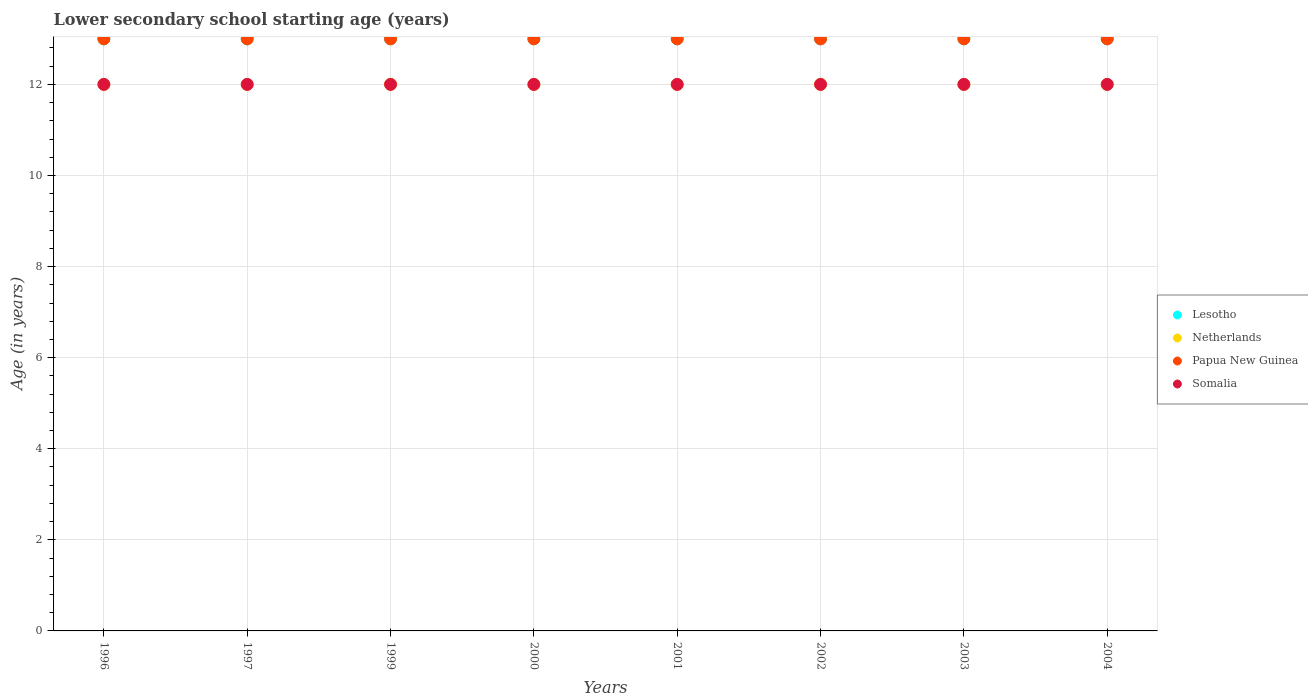Is the number of dotlines equal to the number of legend labels?
Your response must be concise. Yes. What is the lower secondary school starting age of children in Papua New Guinea in 2003?
Offer a terse response. 13. Across all years, what is the maximum lower secondary school starting age of children in Papua New Guinea?
Your answer should be compact. 13. Across all years, what is the minimum lower secondary school starting age of children in Netherlands?
Your response must be concise. 12. In which year was the lower secondary school starting age of children in Netherlands minimum?
Make the answer very short. 1996. What is the total lower secondary school starting age of children in Netherlands in the graph?
Your answer should be compact. 96. What is the difference between the lower secondary school starting age of children in Somalia in 1996 and that in 1999?
Your answer should be compact. 0. In the year 2000, what is the difference between the lower secondary school starting age of children in Somalia and lower secondary school starting age of children in Netherlands?
Make the answer very short. 0. In how many years, is the lower secondary school starting age of children in Netherlands greater than 1.2000000000000002 years?
Provide a succinct answer. 8. Is the difference between the lower secondary school starting age of children in Somalia in 2001 and 2003 greater than the difference between the lower secondary school starting age of children in Netherlands in 2001 and 2003?
Offer a terse response. No. What is the difference between the highest and the second highest lower secondary school starting age of children in Lesotho?
Offer a terse response. 0. Is the sum of the lower secondary school starting age of children in Lesotho in 1999 and 2002 greater than the maximum lower secondary school starting age of children in Papua New Guinea across all years?
Offer a very short reply. Yes. Is it the case that in every year, the sum of the lower secondary school starting age of children in Somalia and lower secondary school starting age of children in Netherlands  is greater than the lower secondary school starting age of children in Papua New Guinea?
Give a very brief answer. Yes. How many dotlines are there?
Offer a very short reply. 4. What is the difference between two consecutive major ticks on the Y-axis?
Make the answer very short. 2. Does the graph contain any zero values?
Provide a succinct answer. No. How are the legend labels stacked?
Provide a succinct answer. Vertical. What is the title of the graph?
Make the answer very short. Lower secondary school starting age (years). What is the label or title of the Y-axis?
Give a very brief answer. Age (in years). What is the Age (in years) of Netherlands in 1996?
Your response must be concise. 12. What is the Age (in years) in Papua New Guinea in 1997?
Provide a short and direct response. 13. What is the Age (in years) of Papua New Guinea in 1999?
Give a very brief answer. 13. What is the Age (in years) in Lesotho in 2001?
Provide a succinct answer. 13. What is the Age (in years) of Papua New Guinea in 2001?
Make the answer very short. 13. What is the Age (in years) in Somalia in 2001?
Give a very brief answer. 12. What is the Age (in years) of Lesotho in 2002?
Your response must be concise. 13. What is the Age (in years) of Papua New Guinea in 2002?
Your answer should be very brief. 13. What is the Age (in years) in Somalia in 2002?
Your answer should be very brief. 12. What is the Age (in years) of Lesotho in 2003?
Your answer should be very brief. 13. What is the Age (in years) in Netherlands in 2003?
Provide a succinct answer. 12. What is the Age (in years) of Papua New Guinea in 2003?
Make the answer very short. 13. What is the Age (in years) of Somalia in 2003?
Offer a terse response. 12. What is the Age (in years) of Lesotho in 2004?
Provide a short and direct response. 13. What is the Age (in years) in Netherlands in 2004?
Ensure brevity in your answer.  12. What is the Age (in years) in Somalia in 2004?
Provide a short and direct response. 12. Across all years, what is the minimum Age (in years) of Lesotho?
Provide a succinct answer. 13. Across all years, what is the minimum Age (in years) in Somalia?
Keep it short and to the point. 12. What is the total Age (in years) of Lesotho in the graph?
Give a very brief answer. 104. What is the total Age (in years) in Netherlands in the graph?
Ensure brevity in your answer.  96. What is the total Age (in years) of Papua New Guinea in the graph?
Keep it short and to the point. 104. What is the total Age (in years) of Somalia in the graph?
Provide a succinct answer. 96. What is the difference between the Age (in years) of Netherlands in 1996 and that in 1997?
Make the answer very short. 0. What is the difference between the Age (in years) in Lesotho in 1996 and that in 1999?
Your answer should be compact. 0. What is the difference between the Age (in years) of Lesotho in 1996 and that in 2000?
Ensure brevity in your answer.  0. What is the difference between the Age (in years) in Somalia in 1996 and that in 2000?
Your answer should be very brief. 0. What is the difference between the Age (in years) of Netherlands in 1996 and that in 2001?
Your answer should be very brief. 0. What is the difference between the Age (in years) in Papua New Guinea in 1996 and that in 2001?
Ensure brevity in your answer.  0. What is the difference between the Age (in years) of Lesotho in 1996 and that in 2002?
Your answer should be compact. 0. What is the difference between the Age (in years) in Netherlands in 1996 and that in 2002?
Your response must be concise. 0. What is the difference between the Age (in years) of Somalia in 1996 and that in 2002?
Offer a terse response. 0. What is the difference between the Age (in years) in Netherlands in 1996 and that in 2003?
Provide a short and direct response. 0. What is the difference between the Age (in years) of Papua New Guinea in 1996 and that in 2003?
Your answer should be compact. 0. What is the difference between the Age (in years) of Netherlands in 1996 and that in 2004?
Your answer should be compact. 0. What is the difference between the Age (in years) of Papua New Guinea in 1996 and that in 2004?
Provide a succinct answer. 0. What is the difference between the Age (in years) of Lesotho in 1997 and that in 1999?
Provide a succinct answer. 0. What is the difference between the Age (in years) in Papua New Guinea in 1997 and that in 1999?
Ensure brevity in your answer.  0. What is the difference between the Age (in years) of Somalia in 1997 and that in 1999?
Your answer should be very brief. 0. What is the difference between the Age (in years) in Papua New Guinea in 1997 and that in 2000?
Offer a very short reply. 0. What is the difference between the Age (in years) in Somalia in 1997 and that in 2000?
Your response must be concise. 0. What is the difference between the Age (in years) of Netherlands in 1997 and that in 2001?
Keep it short and to the point. 0. What is the difference between the Age (in years) of Papua New Guinea in 1997 and that in 2001?
Give a very brief answer. 0. What is the difference between the Age (in years) in Somalia in 1997 and that in 2002?
Your answer should be compact. 0. What is the difference between the Age (in years) in Netherlands in 1997 and that in 2003?
Give a very brief answer. 0. What is the difference between the Age (in years) in Somalia in 1997 and that in 2003?
Your answer should be very brief. 0. What is the difference between the Age (in years) in Netherlands in 1997 and that in 2004?
Your answer should be very brief. 0. What is the difference between the Age (in years) in Papua New Guinea in 1997 and that in 2004?
Your answer should be compact. 0. What is the difference between the Age (in years) of Lesotho in 1999 and that in 2000?
Provide a short and direct response. 0. What is the difference between the Age (in years) in Lesotho in 1999 and that in 2001?
Keep it short and to the point. 0. What is the difference between the Age (in years) in Netherlands in 1999 and that in 2001?
Keep it short and to the point. 0. What is the difference between the Age (in years) in Papua New Guinea in 1999 and that in 2001?
Provide a succinct answer. 0. What is the difference between the Age (in years) of Papua New Guinea in 1999 and that in 2002?
Make the answer very short. 0. What is the difference between the Age (in years) in Somalia in 1999 and that in 2002?
Your answer should be very brief. 0. What is the difference between the Age (in years) of Netherlands in 1999 and that in 2003?
Your answer should be compact. 0. What is the difference between the Age (in years) in Netherlands in 1999 and that in 2004?
Offer a very short reply. 0. What is the difference between the Age (in years) of Papua New Guinea in 2000 and that in 2001?
Keep it short and to the point. 0. What is the difference between the Age (in years) in Lesotho in 2000 and that in 2002?
Offer a very short reply. 0. What is the difference between the Age (in years) of Netherlands in 2000 and that in 2002?
Your answer should be very brief. 0. What is the difference between the Age (in years) of Somalia in 2000 and that in 2003?
Your response must be concise. 0. What is the difference between the Age (in years) in Papua New Guinea in 2000 and that in 2004?
Offer a terse response. 0. What is the difference between the Age (in years) in Somalia in 2000 and that in 2004?
Offer a terse response. 0. What is the difference between the Age (in years) of Lesotho in 2001 and that in 2002?
Keep it short and to the point. 0. What is the difference between the Age (in years) of Somalia in 2001 and that in 2002?
Offer a terse response. 0. What is the difference between the Age (in years) in Papua New Guinea in 2001 and that in 2003?
Make the answer very short. 0. What is the difference between the Age (in years) of Somalia in 2001 and that in 2003?
Offer a terse response. 0. What is the difference between the Age (in years) in Netherlands in 2001 and that in 2004?
Provide a short and direct response. 0. What is the difference between the Age (in years) of Papua New Guinea in 2001 and that in 2004?
Ensure brevity in your answer.  0. What is the difference between the Age (in years) of Somalia in 2001 and that in 2004?
Your answer should be very brief. 0. What is the difference between the Age (in years) of Netherlands in 2002 and that in 2004?
Make the answer very short. 0. What is the difference between the Age (in years) in Papua New Guinea in 2002 and that in 2004?
Offer a terse response. 0. What is the difference between the Age (in years) of Somalia in 2002 and that in 2004?
Give a very brief answer. 0. What is the difference between the Age (in years) of Lesotho in 2003 and that in 2004?
Give a very brief answer. 0. What is the difference between the Age (in years) in Somalia in 2003 and that in 2004?
Ensure brevity in your answer.  0. What is the difference between the Age (in years) in Lesotho in 1996 and the Age (in years) in Papua New Guinea in 1997?
Your answer should be very brief. 0. What is the difference between the Age (in years) of Lesotho in 1996 and the Age (in years) of Somalia in 1997?
Make the answer very short. 1. What is the difference between the Age (in years) in Netherlands in 1996 and the Age (in years) in Somalia in 1997?
Provide a succinct answer. 0. What is the difference between the Age (in years) of Lesotho in 1996 and the Age (in years) of Netherlands in 1999?
Your answer should be compact. 1. What is the difference between the Age (in years) of Lesotho in 1996 and the Age (in years) of Somalia in 1999?
Keep it short and to the point. 1. What is the difference between the Age (in years) in Netherlands in 1996 and the Age (in years) in Papua New Guinea in 1999?
Your answer should be very brief. -1. What is the difference between the Age (in years) of Netherlands in 1996 and the Age (in years) of Somalia in 1999?
Your response must be concise. 0. What is the difference between the Age (in years) in Lesotho in 1996 and the Age (in years) in Netherlands in 2000?
Ensure brevity in your answer.  1. What is the difference between the Age (in years) of Lesotho in 1996 and the Age (in years) of Somalia in 2000?
Keep it short and to the point. 1. What is the difference between the Age (in years) of Papua New Guinea in 1996 and the Age (in years) of Somalia in 2000?
Provide a succinct answer. 1. What is the difference between the Age (in years) in Lesotho in 1996 and the Age (in years) in Netherlands in 2001?
Offer a very short reply. 1. What is the difference between the Age (in years) of Lesotho in 1996 and the Age (in years) of Papua New Guinea in 2001?
Your answer should be very brief. 0. What is the difference between the Age (in years) in Netherlands in 1996 and the Age (in years) in Papua New Guinea in 2001?
Your response must be concise. -1. What is the difference between the Age (in years) of Netherlands in 1996 and the Age (in years) of Somalia in 2001?
Make the answer very short. 0. What is the difference between the Age (in years) in Lesotho in 1996 and the Age (in years) in Netherlands in 2002?
Keep it short and to the point. 1. What is the difference between the Age (in years) in Lesotho in 1996 and the Age (in years) in Papua New Guinea in 2002?
Ensure brevity in your answer.  0. What is the difference between the Age (in years) in Netherlands in 1996 and the Age (in years) in Papua New Guinea in 2002?
Give a very brief answer. -1. What is the difference between the Age (in years) of Papua New Guinea in 1996 and the Age (in years) of Somalia in 2002?
Your answer should be compact. 1. What is the difference between the Age (in years) of Lesotho in 1996 and the Age (in years) of Netherlands in 2003?
Your response must be concise. 1. What is the difference between the Age (in years) of Netherlands in 1996 and the Age (in years) of Somalia in 2003?
Provide a succinct answer. 0. What is the difference between the Age (in years) of Lesotho in 1996 and the Age (in years) of Somalia in 2004?
Your answer should be compact. 1. What is the difference between the Age (in years) of Netherlands in 1996 and the Age (in years) of Somalia in 2004?
Provide a succinct answer. 0. What is the difference between the Age (in years) of Papua New Guinea in 1996 and the Age (in years) of Somalia in 2004?
Your response must be concise. 1. What is the difference between the Age (in years) of Papua New Guinea in 1997 and the Age (in years) of Somalia in 1999?
Make the answer very short. 1. What is the difference between the Age (in years) in Lesotho in 1997 and the Age (in years) in Netherlands in 2000?
Offer a terse response. 1. What is the difference between the Age (in years) of Netherlands in 1997 and the Age (in years) of Papua New Guinea in 2000?
Provide a succinct answer. -1. What is the difference between the Age (in years) of Papua New Guinea in 1997 and the Age (in years) of Somalia in 2000?
Offer a terse response. 1. What is the difference between the Age (in years) of Lesotho in 1997 and the Age (in years) of Netherlands in 2001?
Your answer should be compact. 1. What is the difference between the Age (in years) of Lesotho in 1997 and the Age (in years) of Papua New Guinea in 2001?
Provide a succinct answer. 0. What is the difference between the Age (in years) in Netherlands in 1997 and the Age (in years) in Papua New Guinea in 2001?
Offer a very short reply. -1. What is the difference between the Age (in years) in Papua New Guinea in 1997 and the Age (in years) in Somalia in 2001?
Provide a short and direct response. 1. What is the difference between the Age (in years) in Lesotho in 1997 and the Age (in years) in Papua New Guinea in 2002?
Keep it short and to the point. 0. What is the difference between the Age (in years) in Lesotho in 1997 and the Age (in years) in Somalia in 2002?
Your answer should be compact. 1. What is the difference between the Age (in years) in Netherlands in 1997 and the Age (in years) in Papua New Guinea in 2002?
Offer a terse response. -1. What is the difference between the Age (in years) in Netherlands in 1997 and the Age (in years) in Somalia in 2002?
Make the answer very short. 0. What is the difference between the Age (in years) in Lesotho in 1997 and the Age (in years) in Netherlands in 2003?
Give a very brief answer. 1. What is the difference between the Age (in years) in Lesotho in 1997 and the Age (in years) in Somalia in 2003?
Offer a very short reply. 1. What is the difference between the Age (in years) of Netherlands in 1997 and the Age (in years) of Somalia in 2003?
Your answer should be compact. 0. What is the difference between the Age (in years) of Lesotho in 1997 and the Age (in years) of Netherlands in 2004?
Your answer should be very brief. 1. What is the difference between the Age (in years) of Lesotho in 1999 and the Age (in years) of Netherlands in 2000?
Make the answer very short. 1. What is the difference between the Age (in years) in Lesotho in 1999 and the Age (in years) in Somalia in 2000?
Give a very brief answer. 1. What is the difference between the Age (in years) of Netherlands in 1999 and the Age (in years) of Somalia in 2000?
Offer a terse response. 0. What is the difference between the Age (in years) in Papua New Guinea in 1999 and the Age (in years) in Somalia in 2000?
Provide a short and direct response. 1. What is the difference between the Age (in years) in Lesotho in 1999 and the Age (in years) in Somalia in 2001?
Keep it short and to the point. 1. What is the difference between the Age (in years) of Lesotho in 1999 and the Age (in years) of Papua New Guinea in 2002?
Give a very brief answer. 0. What is the difference between the Age (in years) in Lesotho in 1999 and the Age (in years) in Netherlands in 2003?
Your answer should be very brief. 1. What is the difference between the Age (in years) in Netherlands in 1999 and the Age (in years) in Papua New Guinea in 2003?
Give a very brief answer. -1. What is the difference between the Age (in years) of Netherlands in 1999 and the Age (in years) of Somalia in 2003?
Your answer should be very brief. 0. What is the difference between the Age (in years) in Papua New Guinea in 1999 and the Age (in years) in Somalia in 2003?
Offer a terse response. 1. What is the difference between the Age (in years) in Lesotho in 1999 and the Age (in years) in Papua New Guinea in 2004?
Your answer should be compact. 0. What is the difference between the Age (in years) of Lesotho in 1999 and the Age (in years) of Somalia in 2004?
Keep it short and to the point. 1. What is the difference between the Age (in years) of Netherlands in 1999 and the Age (in years) of Somalia in 2004?
Offer a very short reply. 0. What is the difference between the Age (in years) in Papua New Guinea in 1999 and the Age (in years) in Somalia in 2004?
Your answer should be very brief. 1. What is the difference between the Age (in years) in Netherlands in 2000 and the Age (in years) in Papua New Guinea in 2001?
Provide a short and direct response. -1. What is the difference between the Age (in years) in Netherlands in 2000 and the Age (in years) in Somalia in 2001?
Provide a short and direct response. 0. What is the difference between the Age (in years) of Lesotho in 2000 and the Age (in years) of Netherlands in 2002?
Offer a very short reply. 1. What is the difference between the Age (in years) in Lesotho in 2000 and the Age (in years) in Papua New Guinea in 2002?
Your answer should be compact. 0. What is the difference between the Age (in years) of Lesotho in 2000 and the Age (in years) of Netherlands in 2003?
Your answer should be compact. 1. What is the difference between the Age (in years) of Lesotho in 2000 and the Age (in years) of Papua New Guinea in 2003?
Offer a terse response. 0. What is the difference between the Age (in years) in Netherlands in 2000 and the Age (in years) in Somalia in 2003?
Offer a terse response. 0. What is the difference between the Age (in years) in Lesotho in 2000 and the Age (in years) in Papua New Guinea in 2004?
Give a very brief answer. 0. What is the difference between the Age (in years) in Lesotho in 2001 and the Age (in years) in Papua New Guinea in 2002?
Offer a very short reply. 0. What is the difference between the Age (in years) in Netherlands in 2001 and the Age (in years) in Papua New Guinea in 2002?
Offer a terse response. -1. What is the difference between the Age (in years) of Netherlands in 2001 and the Age (in years) of Somalia in 2002?
Give a very brief answer. 0. What is the difference between the Age (in years) of Papua New Guinea in 2001 and the Age (in years) of Somalia in 2002?
Offer a terse response. 1. What is the difference between the Age (in years) of Lesotho in 2001 and the Age (in years) of Netherlands in 2003?
Provide a succinct answer. 1. What is the difference between the Age (in years) in Lesotho in 2001 and the Age (in years) in Papua New Guinea in 2003?
Make the answer very short. 0. What is the difference between the Age (in years) of Lesotho in 2001 and the Age (in years) of Somalia in 2003?
Your answer should be very brief. 1. What is the difference between the Age (in years) of Netherlands in 2001 and the Age (in years) of Papua New Guinea in 2003?
Ensure brevity in your answer.  -1. What is the difference between the Age (in years) in Lesotho in 2001 and the Age (in years) in Netherlands in 2004?
Your response must be concise. 1. What is the difference between the Age (in years) of Papua New Guinea in 2001 and the Age (in years) of Somalia in 2004?
Make the answer very short. 1. What is the difference between the Age (in years) of Lesotho in 2002 and the Age (in years) of Papua New Guinea in 2003?
Provide a succinct answer. 0. What is the difference between the Age (in years) in Netherlands in 2002 and the Age (in years) in Somalia in 2003?
Your answer should be very brief. 0. What is the difference between the Age (in years) of Papua New Guinea in 2002 and the Age (in years) of Somalia in 2003?
Provide a succinct answer. 1. What is the difference between the Age (in years) in Lesotho in 2002 and the Age (in years) in Netherlands in 2004?
Give a very brief answer. 1. What is the difference between the Age (in years) of Lesotho in 2002 and the Age (in years) of Papua New Guinea in 2004?
Your response must be concise. 0. What is the difference between the Age (in years) in Netherlands in 2002 and the Age (in years) in Papua New Guinea in 2004?
Offer a terse response. -1. What is the difference between the Age (in years) of Netherlands in 2002 and the Age (in years) of Somalia in 2004?
Your answer should be compact. 0. What is the difference between the Age (in years) of Papua New Guinea in 2002 and the Age (in years) of Somalia in 2004?
Make the answer very short. 1. What is the difference between the Age (in years) of Lesotho in 2003 and the Age (in years) of Netherlands in 2004?
Offer a very short reply. 1. What is the difference between the Age (in years) of Lesotho in 2003 and the Age (in years) of Papua New Guinea in 2004?
Offer a terse response. 0. What is the difference between the Age (in years) of Netherlands in 2003 and the Age (in years) of Papua New Guinea in 2004?
Your response must be concise. -1. What is the difference between the Age (in years) in Papua New Guinea in 2003 and the Age (in years) in Somalia in 2004?
Keep it short and to the point. 1. What is the average Age (in years) in Papua New Guinea per year?
Your response must be concise. 13. In the year 1996, what is the difference between the Age (in years) in Lesotho and Age (in years) in Netherlands?
Offer a very short reply. 1. In the year 1996, what is the difference between the Age (in years) in Lesotho and Age (in years) in Papua New Guinea?
Keep it short and to the point. 0. In the year 1996, what is the difference between the Age (in years) of Lesotho and Age (in years) of Somalia?
Your answer should be compact. 1. In the year 1996, what is the difference between the Age (in years) of Netherlands and Age (in years) of Papua New Guinea?
Give a very brief answer. -1. In the year 1996, what is the difference between the Age (in years) in Papua New Guinea and Age (in years) in Somalia?
Your response must be concise. 1. In the year 1997, what is the difference between the Age (in years) in Lesotho and Age (in years) in Somalia?
Offer a terse response. 1. In the year 1997, what is the difference between the Age (in years) of Netherlands and Age (in years) of Somalia?
Make the answer very short. 0. In the year 1997, what is the difference between the Age (in years) of Papua New Guinea and Age (in years) of Somalia?
Provide a succinct answer. 1. In the year 1999, what is the difference between the Age (in years) in Lesotho and Age (in years) in Netherlands?
Give a very brief answer. 1. In the year 1999, what is the difference between the Age (in years) in Lesotho and Age (in years) in Papua New Guinea?
Give a very brief answer. 0. In the year 2001, what is the difference between the Age (in years) in Lesotho and Age (in years) in Netherlands?
Your answer should be very brief. 1. In the year 2001, what is the difference between the Age (in years) in Lesotho and Age (in years) in Papua New Guinea?
Provide a succinct answer. 0. In the year 2001, what is the difference between the Age (in years) in Lesotho and Age (in years) in Somalia?
Offer a very short reply. 1. In the year 2001, what is the difference between the Age (in years) in Netherlands and Age (in years) in Papua New Guinea?
Ensure brevity in your answer.  -1. In the year 2001, what is the difference between the Age (in years) of Papua New Guinea and Age (in years) of Somalia?
Your response must be concise. 1. In the year 2002, what is the difference between the Age (in years) in Lesotho and Age (in years) in Netherlands?
Ensure brevity in your answer.  1. In the year 2002, what is the difference between the Age (in years) of Lesotho and Age (in years) of Papua New Guinea?
Provide a short and direct response. 0. In the year 2002, what is the difference between the Age (in years) in Lesotho and Age (in years) in Somalia?
Keep it short and to the point. 1. In the year 2002, what is the difference between the Age (in years) of Netherlands and Age (in years) of Papua New Guinea?
Give a very brief answer. -1. In the year 2002, what is the difference between the Age (in years) of Papua New Guinea and Age (in years) of Somalia?
Your answer should be very brief. 1. In the year 2003, what is the difference between the Age (in years) in Lesotho and Age (in years) in Papua New Guinea?
Offer a very short reply. 0. In the year 2003, what is the difference between the Age (in years) in Lesotho and Age (in years) in Somalia?
Your response must be concise. 1. In the year 2004, what is the difference between the Age (in years) of Lesotho and Age (in years) of Netherlands?
Provide a succinct answer. 1. In the year 2004, what is the difference between the Age (in years) of Netherlands and Age (in years) of Somalia?
Offer a very short reply. 0. What is the ratio of the Age (in years) of Netherlands in 1996 to that in 1997?
Keep it short and to the point. 1. What is the ratio of the Age (in years) in Somalia in 1996 to that in 1997?
Your answer should be compact. 1. What is the ratio of the Age (in years) of Lesotho in 1996 to that in 2000?
Make the answer very short. 1. What is the ratio of the Age (in years) of Somalia in 1996 to that in 2000?
Offer a very short reply. 1. What is the ratio of the Age (in years) of Netherlands in 1996 to that in 2001?
Your response must be concise. 1. What is the ratio of the Age (in years) in Somalia in 1996 to that in 2001?
Your answer should be compact. 1. What is the ratio of the Age (in years) in Netherlands in 1996 to that in 2002?
Give a very brief answer. 1. What is the ratio of the Age (in years) of Netherlands in 1996 to that in 2003?
Provide a short and direct response. 1. What is the ratio of the Age (in years) of Papua New Guinea in 1996 to that in 2003?
Your answer should be compact. 1. What is the ratio of the Age (in years) of Lesotho in 1996 to that in 2004?
Keep it short and to the point. 1. What is the ratio of the Age (in years) of Netherlands in 1996 to that in 2004?
Provide a short and direct response. 1. What is the ratio of the Age (in years) in Papua New Guinea in 1996 to that in 2004?
Ensure brevity in your answer.  1. What is the ratio of the Age (in years) of Somalia in 1996 to that in 2004?
Ensure brevity in your answer.  1. What is the ratio of the Age (in years) in Netherlands in 1997 to that in 1999?
Give a very brief answer. 1. What is the ratio of the Age (in years) in Somalia in 1997 to that in 1999?
Your answer should be very brief. 1. What is the ratio of the Age (in years) of Papua New Guinea in 1997 to that in 2000?
Offer a terse response. 1. What is the ratio of the Age (in years) in Lesotho in 1997 to that in 2001?
Make the answer very short. 1. What is the ratio of the Age (in years) of Netherlands in 1997 to that in 2001?
Offer a terse response. 1. What is the ratio of the Age (in years) of Somalia in 1997 to that in 2001?
Make the answer very short. 1. What is the ratio of the Age (in years) of Lesotho in 1997 to that in 2002?
Offer a very short reply. 1. What is the ratio of the Age (in years) in Papua New Guinea in 1997 to that in 2002?
Provide a succinct answer. 1. What is the ratio of the Age (in years) in Somalia in 1997 to that in 2002?
Offer a terse response. 1. What is the ratio of the Age (in years) in Lesotho in 1997 to that in 2003?
Offer a very short reply. 1. What is the ratio of the Age (in years) in Netherlands in 1997 to that in 2003?
Your answer should be compact. 1. What is the ratio of the Age (in years) in Somalia in 1997 to that in 2003?
Your response must be concise. 1. What is the ratio of the Age (in years) of Lesotho in 1997 to that in 2004?
Offer a terse response. 1. What is the ratio of the Age (in years) of Somalia in 1997 to that in 2004?
Give a very brief answer. 1. What is the ratio of the Age (in years) of Netherlands in 1999 to that in 2000?
Offer a terse response. 1. What is the ratio of the Age (in years) in Papua New Guinea in 1999 to that in 2000?
Offer a terse response. 1. What is the ratio of the Age (in years) of Somalia in 1999 to that in 2000?
Provide a succinct answer. 1. What is the ratio of the Age (in years) of Netherlands in 1999 to that in 2001?
Your response must be concise. 1. What is the ratio of the Age (in years) of Papua New Guinea in 1999 to that in 2001?
Offer a very short reply. 1. What is the ratio of the Age (in years) in Lesotho in 1999 to that in 2002?
Give a very brief answer. 1. What is the ratio of the Age (in years) of Papua New Guinea in 1999 to that in 2002?
Give a very brief answer. 1. What is the ratio of the Age (in years) in Netherlands in 1999 to that in 2003?
Offer a very short reply. 1. What is the ratio of the Age (in years) of Lesotho in 1999 to that in 2004?
Your response must be concise. 1. What is the ratio of the Age (in years) of Netherlands in 1999 to that in 2004?
Provide a short and direct response. 1. What is the ratio of the Age (in years) in Papua New Guinea in 1999 to that in 2004?
Your response must be concise. 1. What is the ratio of the Age (in years) of Lesotho in 2000 to that in 2001?
Provide a succinct answer. 1. What is the ratio of the Age (in years) in Somalia in 2000 to that in 2001?
Ensure brevity in your answer.  1. What is the ratio of the Age (in years) of Lesotho in 2000 to that in 2002?
Offer a terse response. 1. What is the ratio of the Age (in years) of Netherlands in 2000 to that in 2002?
Provide a short and direct response. 1. What is the ratio of the Age (in years) of Somalia in 2000 to that in 2002?
Provide a succinct answer. 1. What is the ratio of the Age (in years) of Lesotho in 2000 to that in 2003?
Your answer should be compact. 1. What is the ratio of the Age (in years) of Papua New Guinea in 2000 to that in 2004?
Give a very brief answer. 1. What is the ratio of the Age (in years) in Somalia in 2000 to that in 2004?
Keep it short and to the point. 1. What is the ratio of the Age (in years) of Netherlands in 2001 to that in 2002?
Provide a short and direct response. 1. What is the ratio of the Age (in years) in Papua New Guinea in 2001 to that in 2002?
Ensure brevity in your answer.  1. What is the ratio of the Age (in years) of Lesotho in 2001 to that in 2003?
Ensure brevity in your answer.  1. What is the ratio of the Age (in years) in Netherlands in 2001 to that in 2003?
Provide a succinct answer. 1. What is the ratio of the Age (in years) in Papua New Guinea in 2001 to that in 2003?
Provide a short and direct response. 1. What is the ratio of the Age (in years) in Somalia in 2001 to that in 2003?
Your answer should be compact. 1. What is the ratio of the Age (in years) of Papua New Guinea in 2001 to that in 2004?
Your response must be concise. 1. What is the ratio of the Age (in years) of Somalia in 2001 to that in 2004?
Give a very brief answer. 1. What is the ratio of the Age (in years) of Lesotho in 2002 to that in 2003?
Make the answer very short. 1. What is the ratio of the Age (in years) of Netherlands in 2002 to that in 2003?
Give a very brief answer. 1. What is the ratio of the Age (in years) in Somalia in 2002 to that in 2004?
Provide a succinct answer. 1. What is the ratio of the Age (in years) in Papua New Guinea in 2003 to that in 2004?
Give a very brief answer. 1. What is the ratio of the Age (in years) of Somalia in 2003 to that in 2004?
Offer a terse response. 1. What is the difference between the highest and the second highest Age (in years) of Lesotho?
Offer a terse response. 0. What is the difference between the highest and the second highest Age (in years) in Papua New Guinea?
Give a very brief answer. 0. What is the difference between the highest and the lowest Age (in years) of Papua New Guinea?
Give a very brief answer. 0. 